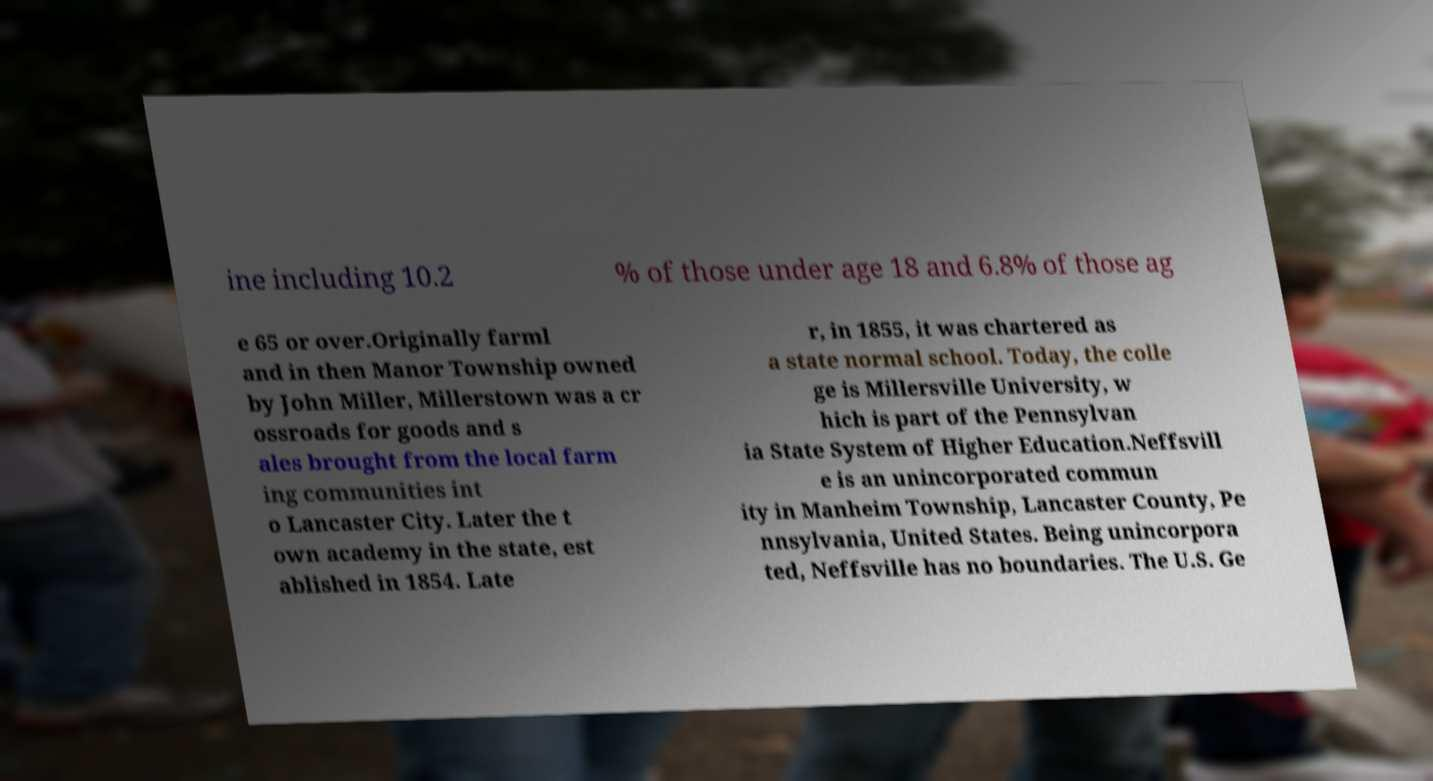There's text embedded in this image that I need extracted. Can you transcribe it verbatim? ine including 10.2 % of those under age 18 and 6.8% of those ag e 65 or over.Originally farml and in then Manor Township owned by John Miller, Millerstown was a cr ossroads for goods and s ales brought from the local farm ing communities int o Lancaster City. Later the t own academy in the state, est ablished in 1854. Late r, in 1855, it was chartered as a state normal school. Today, the colle ge is Millersville University, w hich is part of the Pennsylvan ia State System of Higher Education.Neffsvill e is an unincorporated commun ity in Manheim Township, Lancaster County, Pe nnsylvania, United States. Being unincorpora ted, Neffsville has no boundaries. The U.S. Ge 